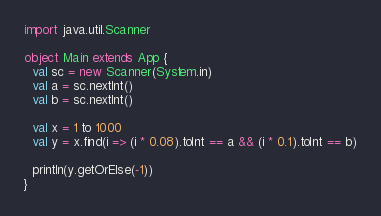<code> <loc_0><loc_0><loc_500><loc_500><_Scala_>import java.util.Scanner

object Main extends App {
  val sc = new Scanner(System.in)
  val a = sc.nextInt()
  val b = sc.nextInt()

  val x = 1 to 1000
  val y = x.find(i => (i * 0.08).toInt == a && (i * 0.1).toInt == b)

  println(y.getOrElse(-1))
}
</code> 